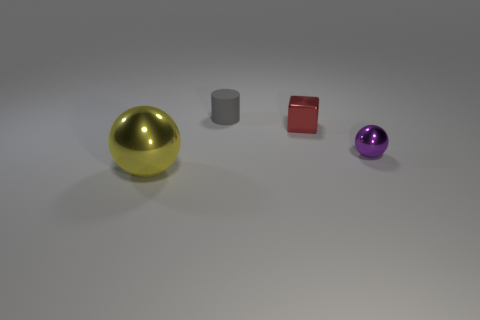Add 4 large brown shiny cubes. How many objects exist? 8 Subtract all cylinders. How many objects are left? 3 Subtract all small gray metal blocks. Subtract all tiny metal blocks. How many objects are left? 3 Add 1 small gray cylinders. How many small gray cylinders are left? 2 Add 2 big spheres. How many big spheres exist? 3 Subtract 1 red cubes. How many objects are left? 3 